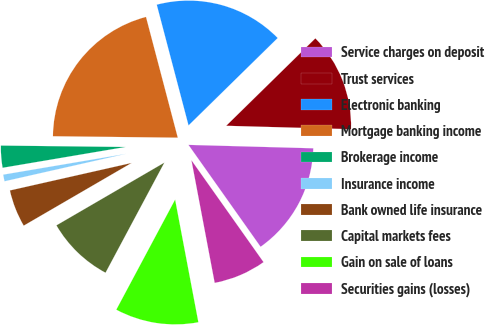Convert chart to OTSL. <chart><loc_0><loc_0><loc_500><loc_500><pie_chart><fcel>Service charges on deposit<fcel>Trust services<fcel>Electronic banking<fcel>Mortgage banking income<fcel>Brokerage income<fcel>Insurance income<fcel>Bank owned life insurance<fcel>Capital markets fees<fcel>Gain on sale of loans<fcel>Securities gains (losses)<nl><fcel>14.76%<fcel>12.78%<fcel>16.75%<fcel>20.72%<fcel>2.85%<fcel>0.87%<fcel>4.84%<fcel>8.81%<fcel>10.79%<fcel>6.82%<nl></chart> 